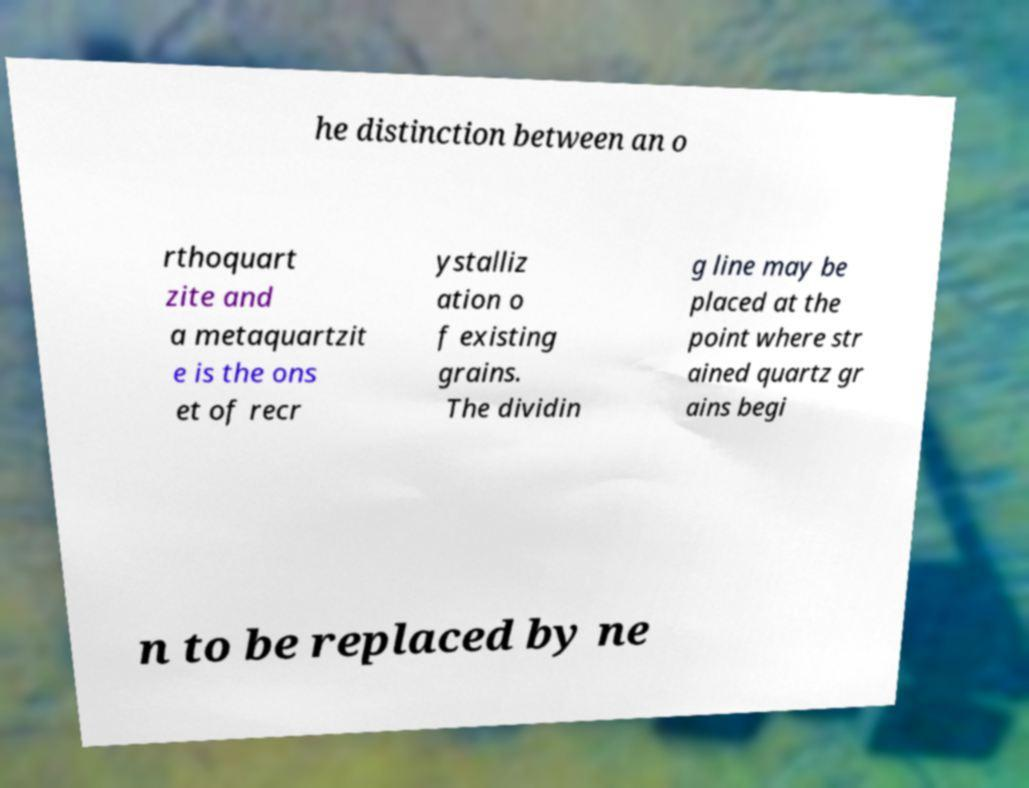Can you accurately transcribe the text from the provided image for me? he distinction between an o rthoquart zite and a metaquartzit e is the ons et of recr ystalliz ation o f existing grains. The dividin g line may be placed at the point where str ained quartz gr ains begi n to be replaced by ne 